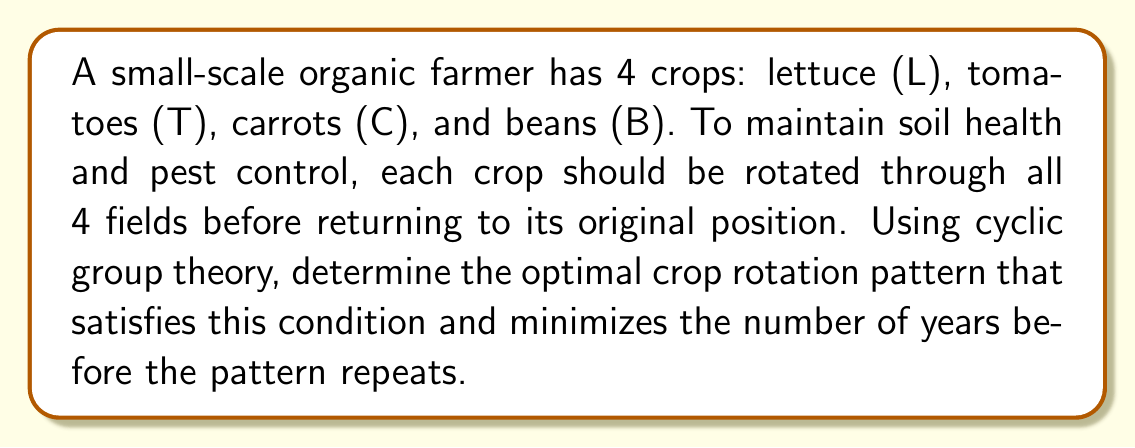Solve this math problem. 1. We can represent the crops as elements of a cyclic group $C_4$ of order 4.

2. The group operation is rotation, which corresponds to moving each crop to the next field.

3. We need to find a generator of $C_4$ that creates a cycle including all elements before repeating.

4. The possible generators are:
   $g_1 = (L \; T \; C \; B)$
   $g_2 = (L \; C \; B \; T)$
   $g_3 = (L \; B \; T \; C)$

5. Any of these generators will create a valid 4-year rotation pattern. Let's choose $g_1$.

6. The rotation pattern using $g_1$ is:
   Year 1: $(L \; T \; C \; B)$
   Year 2: $(B \; L \; T \; C)$
   Year 3: $(C \; B \; L \; T)$
   Year 4: $(T \; C \; B \; L)$

7. This pattern ensures each crop rotates through all fields before returning to its original position.

8. The pattern repeats after 4 years, which is the order of the cyclic group $C_4$.
Answer: $(L \; T \; C \; B)$ 